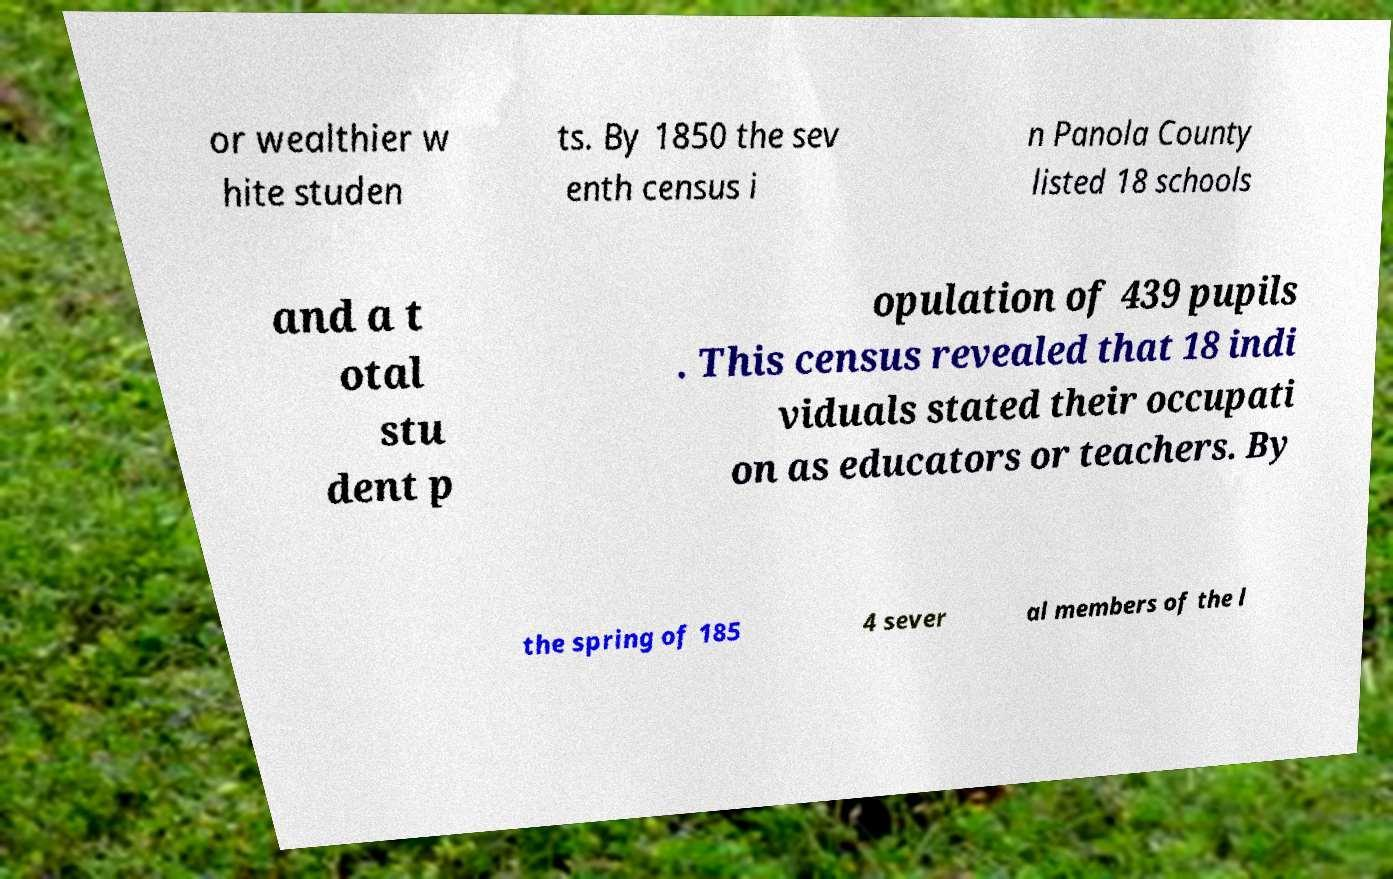Can you accurately transcribe the text from the provided image for me? or wealthier w hite studen ts. By 1850 the sev enth census i n Panola County listed 18 schools and a t otal stu dent p opulation of 439 pupils . This census revealed that 18 indi viduals stated their occupati on as educators or teachers. By the spring of 185 4 sever al members of the l 